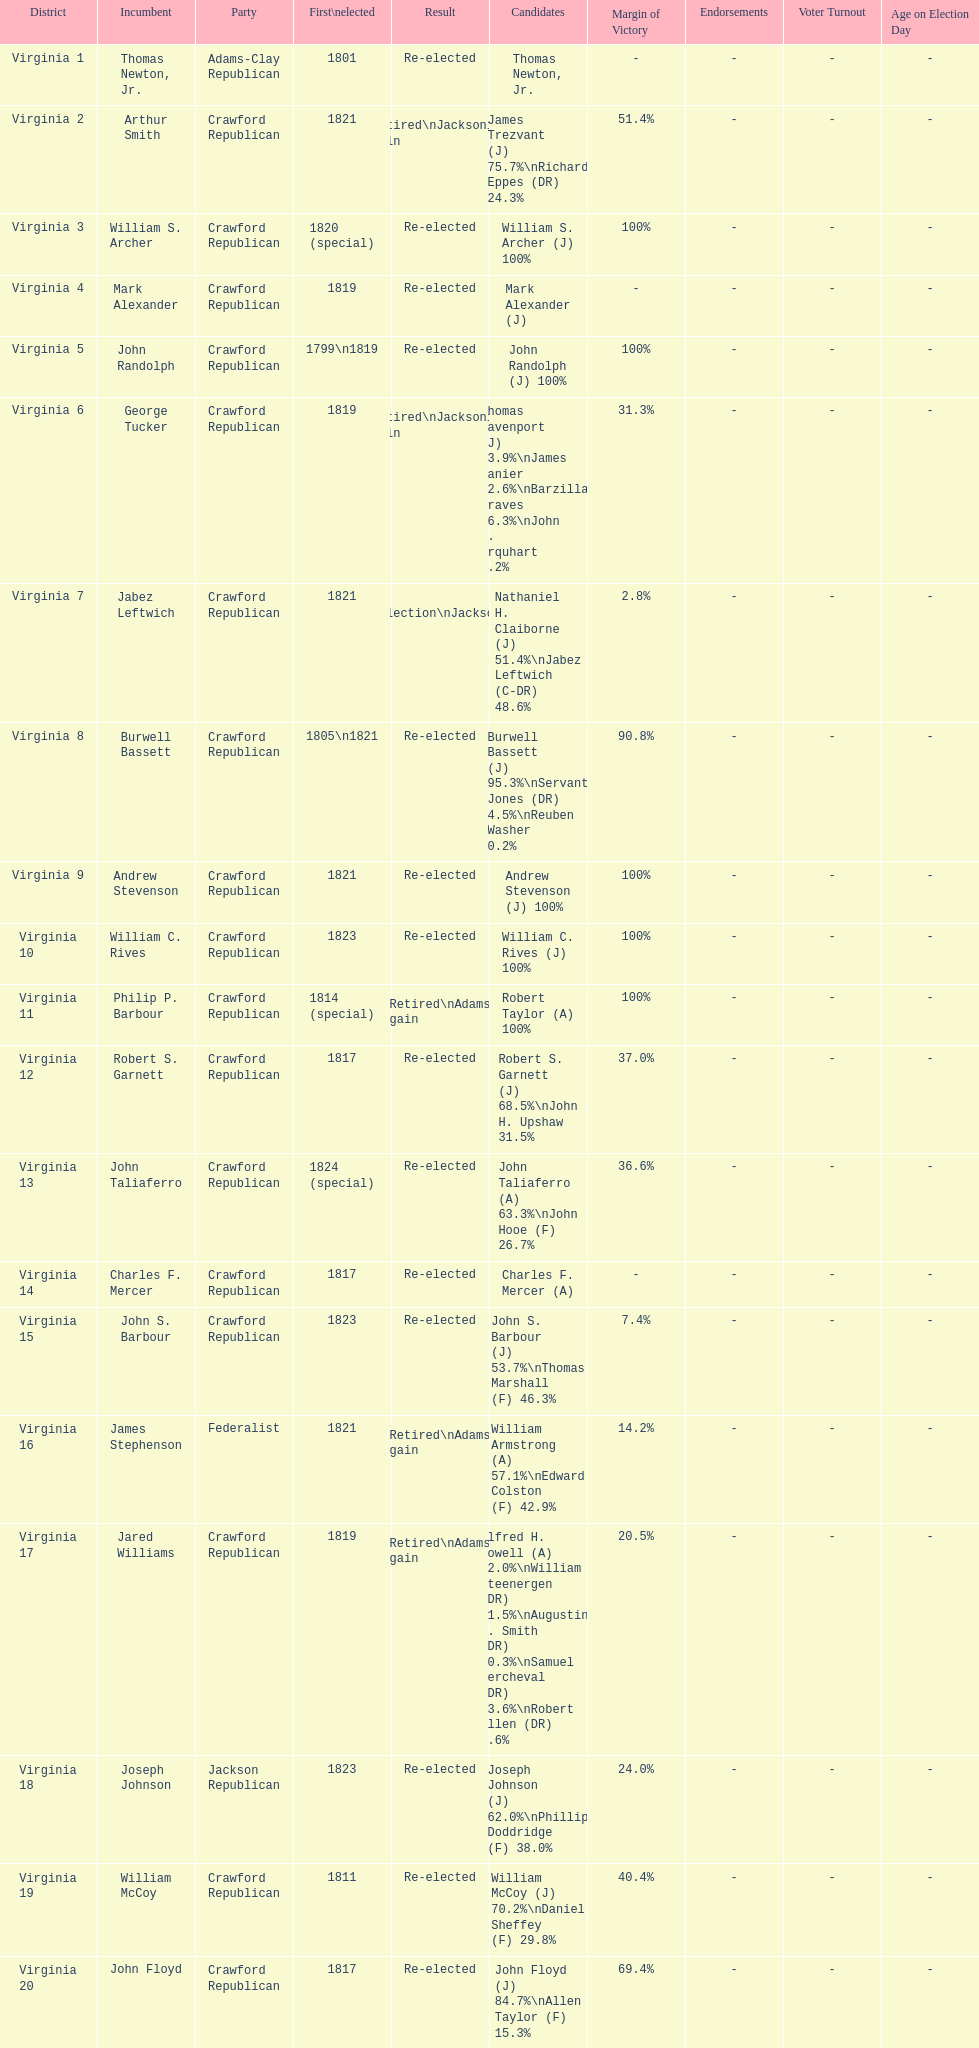Number of incumbents who retired or lost re-election 7. 